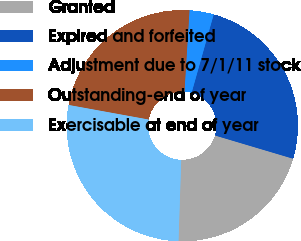Convert chart to OTSL. <chart><loc_0><loc_0><loc_500><loc_500><pie_chart><fcel>Granted<fcel>Expired and forfeited<fcel>Adjustment due to 7/1/11 stock<fcel>Outstanding-end of year<fcel>Exercisable at end of year<nl><fcel>20.93%<fcel>25.23%<fcel>3.39%<fcel>23.12%<fcel>27.34%<nl></chart> 